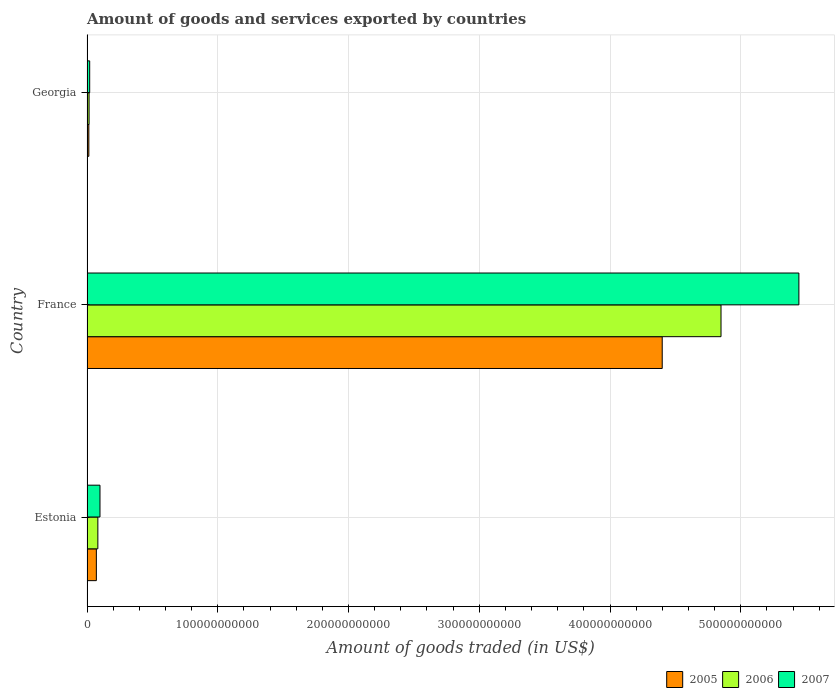How many different coloured bars are there?
Give a very brief answer. 3. How many groups of bars are there?
Offer a terse response. 3. Are the number of bars per tick equal to the number of legend labels?
Keep it short and to the point. Yes. How many bars are there on the 1st tick from the top?
Provide a short and direct response. 3. How many bars are there on the 2nd tick from the bottom?
Provide a short and direct response. 3. What is the label of the 2nd group of bars from the top?
Provide a short and direct response. France. What is the total amount of goods and services exported in 2006 in France?
Provide a short and direct response. 4.85e+11. Across all countries, what is the maximum total amount of goods and services exported in 2006?
Ensure brevity in your answer.  4.85e+11. Across all countries, what is the minimum total amount of goods and services exported in 2005?
Make the answer very short. 1.41e+09. In which country was the total amount of goods and services exported in 2005 maximum?
Ensure brevity in your answer.  France. In which country was the total amount of goods and services exported in 2007 minimum?
Your answer should be very brief. Georgia. What is the total total amount of goods and services exported in 2005 in the graph?
Offer a very short reply. 4.48e+11. What is the difference between the total amount of goods and services exported in 2005 in France and that in Georgia?
Give a very brief answer. 4.38e+11. What is the difference between the total amount of goods and services exported in 2006 in France and the total amount of goods and services exported in 2007 in Georgia?
Your answer should be compact. 4.83e+11. What is the average total amount of goods and services exported in 2007 per country?
Make the answer very short. 1.85e+11. What is the difference between the total amount of goods and services exported in 2006 and total amount of goods and services exported in 2007 in Estonia?
Provide a succinct answer. -1.62e+09. What is the ratio of the total amount of goods and services exported in 2005 in France to that in Georgia?
Your answer should be very brief. 311.12. Is the difference between the total amount of goods and services exported in 2006 in Estonia and France greater than the difference between the total amount of goods and services exported in 2007 in Estonia and France?
Offer a terse response. Yes. What is the difference between the highest and the second highest total amount of goods and services exported in 2007?
Keep it short and to the point. 5.34e+11. What is the difference between the highest and the lowest total amount of goods and services exported in 2007?
Your answer should be very brief. 5.42e+11. In how many countries, is the total amount of goods and services exported in 2007 greater than the average total amount of goods and services exported in 2007 taken over all countries?
Offer a terse response. 1. What does the 1st bar from the top in Estonia represents?
Make the answer very short. 2007. How many bars are there?
Keep it short and to the point. 9. How many countries are there in the graph?
Give a very brief answer. 3. What is the difference between two consecutive major ticks on the X-axis?
Your answer should be compact. 1.00e+11. Are the values on the major ticks of X-axis written in scientific E-notation?
Provide a succinct answer. No. Does the graph contain any zero values?
Provide a succinct answer. No. Where does the legend appear in the graph?
Offer a terse response. Bottom right. How many legend labels are there?
Your answer should be very brief. 3. What is the title of the graph?
Give a very brief answer. Amount of goods and services exported by countries. What is the label or title of the X-axis?
Offer a terse response. Amount of goods traded (in US$). What is the Amount of goods traded (in US$) in 2005 in Estonia?
Offer a very short reply. 7.16e+09. What is the Amount of goods traded (in US$) of 2006 in Estonia?
Offer a very short reply. 8.31e+09. What is the Amount of goods traded (in US$) in 2007 in Estonia?
Provide a succinct answer. 9.93e+09. What is the Amount of goods traded (in US$) in 2005 in France?
Ensure brevity in your answer.  4.40e+11. What is the Amount of goods traded (in US$) of 2006 in France?
Provide a succinct answer. 4.85e+11. What is the Amount of goods traded (in US$) in 2007 in France?
Your answer should be very brief. 5.44e+11. What is the Amount of goods traded (in US$) of 2005 in Georgia?
Provide a succinct answer. 1.41e+09. What is the Amount of goods traded (in US$) in 2006 in Georgia?
Your answer should be compact. 1.59e+09. What is the Amount of goods traded (in US$) of 2007 in Georgia?
Your answer should be very brief. 2.06e+09. Across all countries, what is the maximum Amount of goods traded (in US$) of 2005?
Provide a succinct answer. 4.40e+11. Across all countries, what is the maximum Amount of goods traded (in US$) of 2006?
Offer a terse response. 4.85e+11. Across all countries, what is the maximum Amount of goods traded (in US$) of 2007?
Offer a very short reply. 5.44e+11. Across all countries, what is the minimum Amount of goods traded (in US$) in 2005?
Your response must be concise. 1.41e+09. Across all countries, what is the minimum Amount of goods traded (in US$) of 2006?
Make the answer very short. 1.59e+09. Across all countries, what is the minimum Amount of goods traded (in US$) of 2007?
Your response must be concise. 2.06e+09. What is the total Amount of goods traded (in US$) of 2005 in the graph?
Make the answer very short. 4.48e+11. What is the total Amount of goods traded (in US$) in 2006 in the graph?
Your answer should be very brief. 4.95e+11. What is the total Amount of goods traded (in US$) in 2007 in the graph?
Give a very brief answer. 5.56e+11. What is the difference between the Amount of goods traded (in US$) of 2005 in Estonia and that in France?
Ensure brevity in your answer.  -4.33e+11. What is the difference between the Amount of goods traded (in US$) of 2006 in Estonia and that in France?
Give a very brief answer. -4.77e+11. What is the difference between the Amount of goods traded (in US$) of 2007 in Estonia and that in France?
Ensure brevity in your answer.  -5.34e+11. What is the difference between the Amount of goods traded (in US$) of 2005 in Estonia and that in Georgia?
Provide a succinct answer. 5.75e+09. What is the difference between the Amount of goods traded (in US$) in 2006 in Estonia and that in Georgia?
Provide a succinct answer. 6.72e+09. What is the difference between the Amount of goods traded (in US$) of 2007 in Estonia and that in Georgia?
Ensure brevity in your answer.  7.87e+09. What is the difference between the Amount of goods traded (in US$) in 2005 in France and that in Georgia?
Keep it short and to the point. 4.38e+11. What is the difference between the Amount of goods traded (in US$) of 2006 in France and that in Georgia?
Provide a succinct answer. 4.83e+11. What is the difference between the Amount of goods traded (in US$) in 2007 in France and that in Georgia?
Keep it short and to the point. 5.42e+11. What is the difference between the Amount of goods traded (in US$) in 2005 in Estonia and the Amount of goods traded (in US$) in 2006 in France?
Offer a terse response. -4.78e+11. What is the difference between the Amount of goods traded (in US$) of 2005 in Estonia and the Amount of goods traded (in US$) of 2007 in France?
Provide a succinct answer. -5.37e+11. What is the difference between the Amount of goods traded (in US$) of 2006 in Estonia and the Amount of goods traded (in US$) of 2007 in France?
Your response must be concise. -5.36e+11. What is the difference between the Amount of goods traded (in US$) in 2005 in Estonia and the Amount of goods traded (in US$) in 2006 in Georgia?
Offer a terse response. 5.57e+09. What is the difference between the Amount of goods traded (in US$) of 2005 in Estonia and the Amount of goods traded (in US$) of 2007 in Georgia?
Make the answer very short. 5.10e+09. What is the difference between the Amount of goods traded (in US$) of 2006 in Estonia and the Amount of goods traded (in US$) of 2007 in Georgia?
Your response must be concise. 6.25e+09. What is the difference between the Amount of goods traded (in US$) of 2005 in France and the Amount of goods traded (in US$) of 2006 in Georgia?
Provide a succinct answer. 4.38e+11. What is the difference between the Amount of goods traded (in US$) in 2005 in France and the Amount of goods traded (in US$) in 2007 in Georgia?
Ensure brevity in your answer.  4.38e+11. What is the difference between the Amount of goods traded (in US$) in 2006 in France and the Amount of goods traded (in US$) in 2007 in Georgia?
Your answer should be compact. 4.83e+11. What is the average Amount of goods traded (in US$) of 2005 per country?
Provide a succinct answer. 1.49e+11. What is the average Amount of goods traded (in US$) in 2006 per country?
Your answer should be very brief. 1.65e+11. What is the average Amount of goods traded (in US$) in 2007 per country?
Make the answer very short. 1.85e+11. What is the difference between the Amount of goods traded (in US$) of 2005 and Amount of goods traded (in US$) of 2006 in Estonia?
Provide a succinct answer. -1.15e+09. What is the difference between the Amount of goods traded (in US$) in 2005 and Amount of goods traded (in US$) in 2007 in Estonia?
Ensure brevity in your answer.  -2.77e+09. What is the difference between the Amount of goods traded (in US$) in 2006 and Amount of goods traded (in US$) in 2007 in Estonia?
Keep it short and to the point. -1.62e+09. What is the difference between the Amount of goods traded (in US$) of 2005 and Amount of goods traded (in US$) of 2006 in France?
Make the answer very short. -4.50e+1. What is the difference between the Amount of goods traded (in US$) in 2005 and Amount of goods traded (in US$) in 2007 in France?
Your answer should be very brief. -1.05e+11. What is the difference between the Amount of goods traded (in US$) of 2006 and Amount of goods traded (in US$) of 2007 in France?
Offer a terse response. -5.96e+1. What is the difference between the Amount of goods traded (in US$) in 2005 and Amount of goods traded (in US$) in 2006 in Georgia?
Your answer should be very brief. -1.73e+08. What is the difference between the Amount of goods traded (in US$) in 2005 and Amount of goods traded (in US$) in 2007 in Georgia?
Provide a succinct answer. -6.42e+08. What is the difference between the Amount of goods traded (in US$) of 2006 and Amount of goods traded (in US$) of 2007 in Georgia?
Ensure brevity in your answer.  -4.69e+08. What is the ratio of the Amount of goods traded (in US$) of 2005 in Estonia to that in France?
Your response must be concise. 0.02. What is the ratio of the Amount of goods traded (in US$) in 2006 in Estonia to that in France?
Give a very brief answer. 0.02. What is the ratio of the Amount of goods traded (in US$) in 2007 in Estonia to that in France?
Offer a very short reply. 0.02. What is the ratio of the Amount of goods traded (in US$) of 2005 in Estonia to that in Georgia?
Your response must be concise. 5.06. What is the ratio of the Amount of goods traded (in US$) of 2006 in Estonia to that in Georgia?
Provide a short and direct response. 5.24. What is the ratio of the Amount of goods traded (in US$) in 2007 in Estonia to that in Georgia?
Your answer should be compact. 4.83. What is the ratio of the Amount of goods traded (in US$) of 2005 in France to that in Georgia?
Give a very brief answer. 311.12. What is the ratio of the Amount of goods traded (in US$) of 2006 in France to that in Georgia?
Offer a very short reply. 305.63. What is the ratio of the Amount of goods traded (in US$) of 2007 in France to that in Georgia?
Your answer should be compact. 264.84. What is the difference between the highest and the second highest Amount of goods traded (in US$) of 2005?
Keep it short and to the point. 4.33e+11. What is the difference between the highest and the second highest Amount of goods traded (in US$) in 2006?
Your answer should be very brief. 4.77e+11. What is the difference between the highest and the second highest Amount of goods traded (in US$) of 2007?
Ensure brevity in your answer.  5.34e+11. What is the difference between the highest and the lowest Amount of goods traded (in US$) of 2005?
Your answer should be very brief. 4.38e+11. What is the difference between the highest and the lowest Amount of goods traded (in US$) of 2006?
Your answer should be very brief. 4.83e+11. What is the difference between the highest and the lowest Amount of goods traded (in US$) in 2007?
Keep it short and to the point. 5.42e+11. 